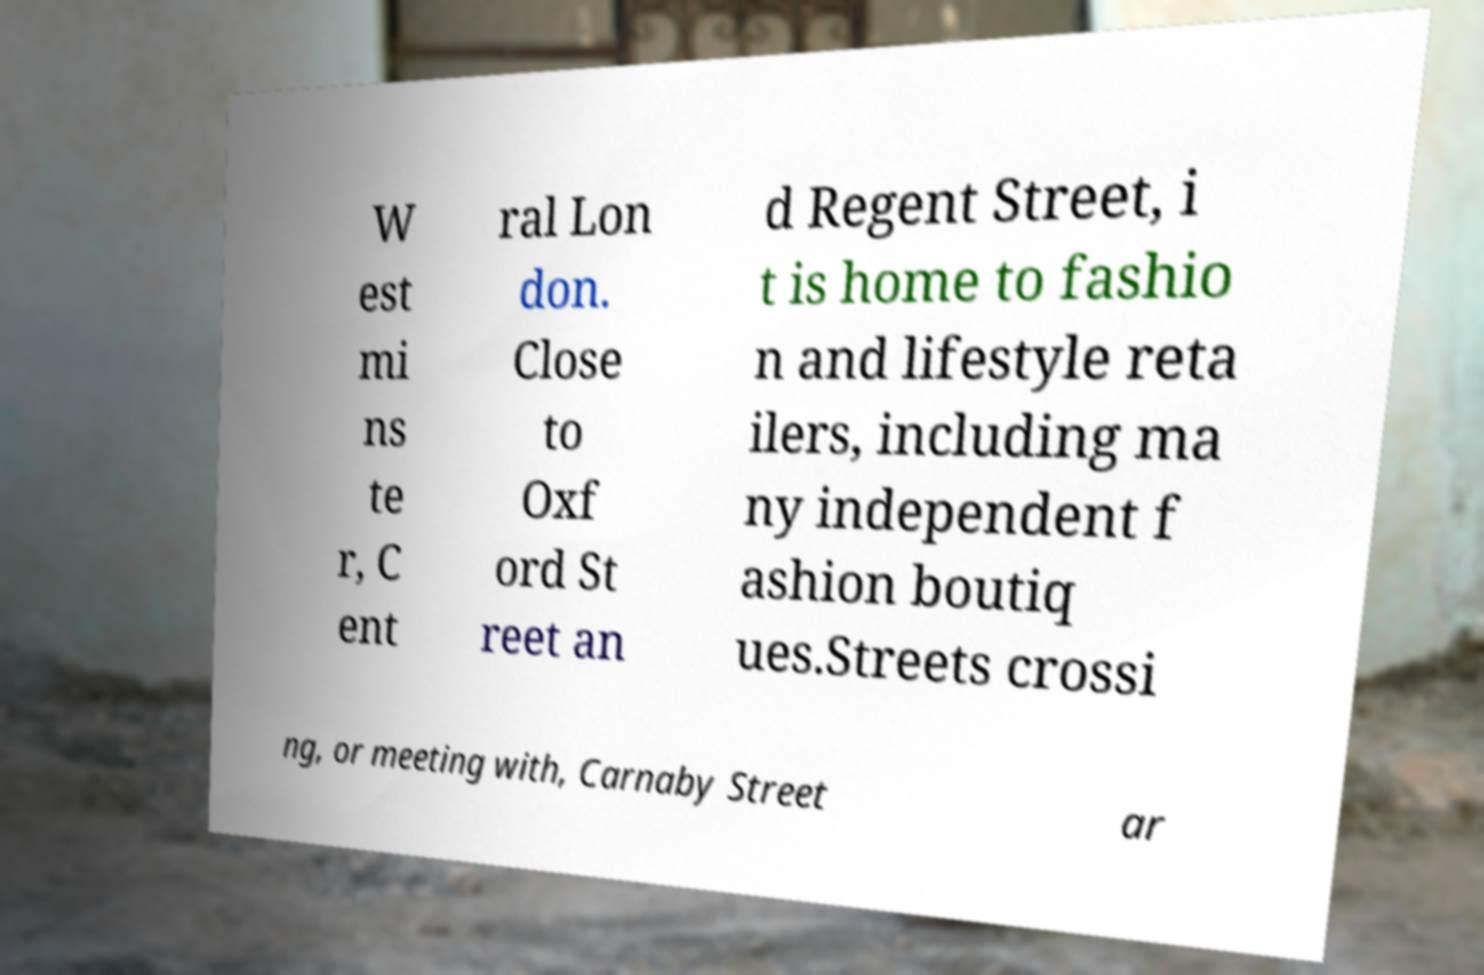Could you extract and type out the text from this image? W est mi ns te r, C ent ral Lon don. Close to Oxf ord St reet an d Regent Street, i t is home to fashio n and lifestyle reta ilers, including ma ny independent f ashion boutiq ues.Streets crossi ng, or meeting with, Carnaby Street ar 